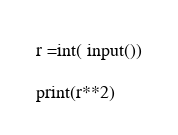Convert code to text. <code><loc_0><loc_0><loc_500><loc_500><_Python_>r =int( input())

print(r**2)
</code> 